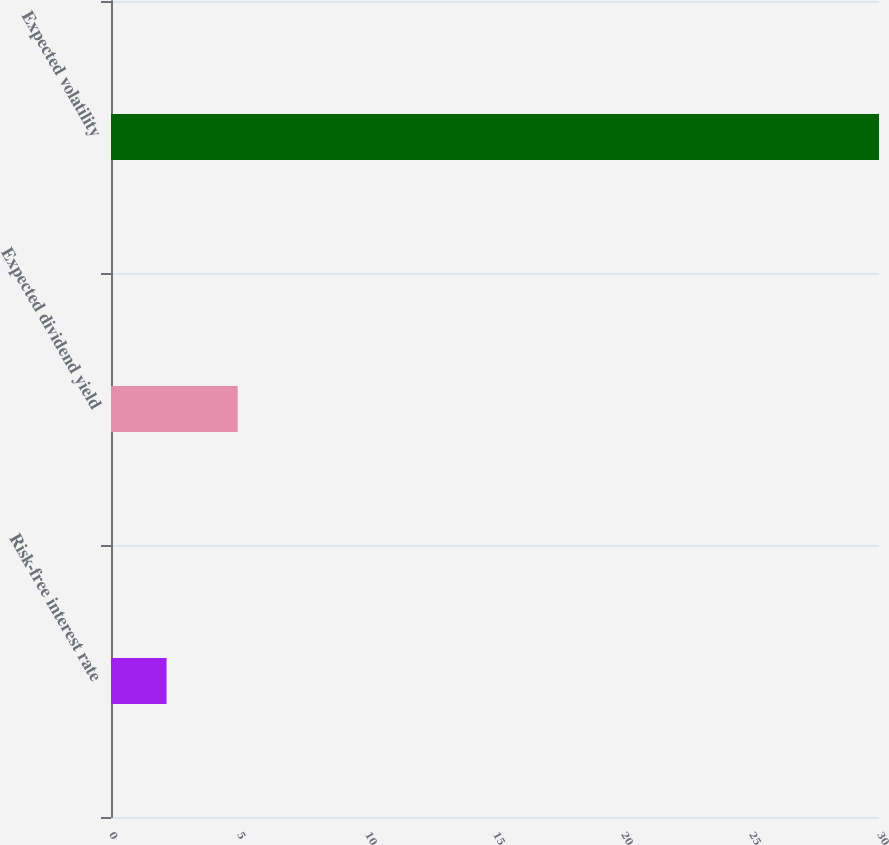Convert chart. <chart><loc_0><loc_0><loc_500><loc_500><bar_chart><fcel>Risk-free interest rate<fcel>Expected dividend yield<fcel>Expected volatility<nl><fcel>2.17<fcel>4.95<fcel>30<nl></chart> 